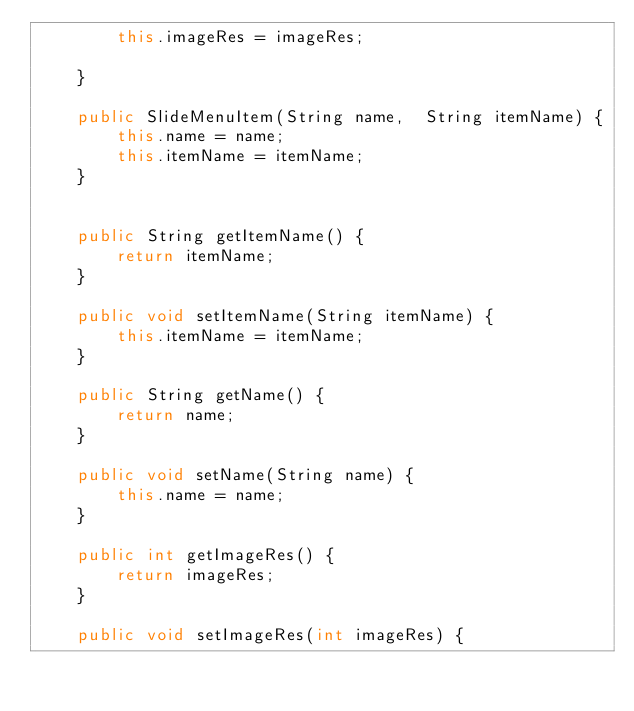<code> <loc_0><loc_0><loc_500><loc_500><_Java_>        this.imageRes = imageRes;

    }

    public SlideMenuItem(String name,  String itemName) {
        this.name = name;
        this.itemName = itemName;
    }


    public String getItemName() {
        return itemName;
    }

    public void setItemName(String itemName) {
        this.itemName = itemName;
    }

    public String getName() {
        return name;
    }

    public void setName(String name) {
        this.name = name;
    }

    public int getImageRes() {
        return imageRes;
    }

    public void setImageRes(int imageRes) {</code> 